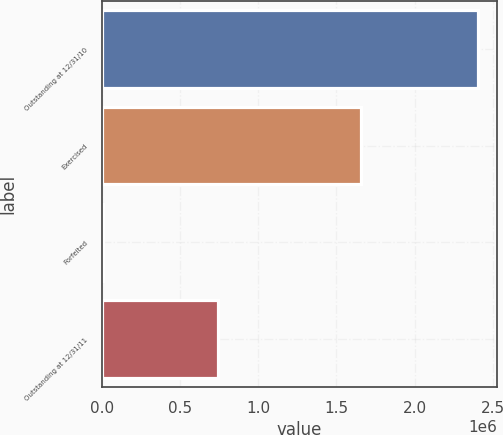Convert chart to OTSL. <chart><loc_0><loc_0><loc_500><loc_500><bar_chart><fcel>Outstanding at 12/31/10<fcel>Exercised<fcel>Forfeited<fcel>Outstanding at 12/31/11<nl><fcel>2.4067e+06<fcel>1.65658e+06<fcel>9250<fcel>740875<nl></chart> 